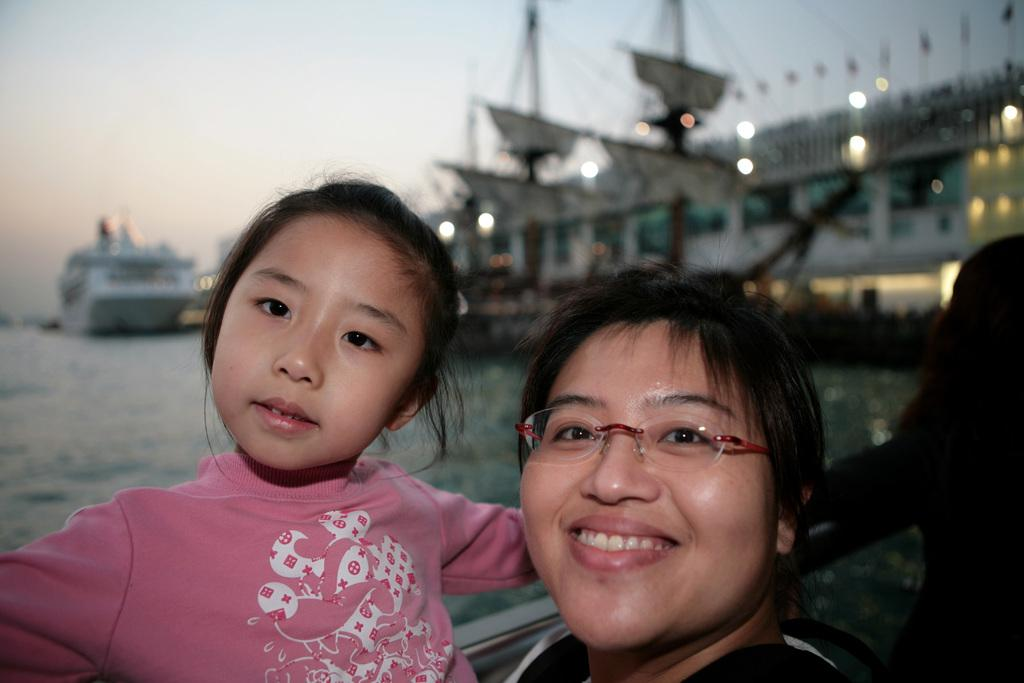How many people are in the foreground of the image? There are three persons in the foreground of the image. What are the persons near in the image? The persons are near a fence in the image. What can be seen in the background of the image? In the background of the image, there are boats in the water, buildings, lights, and the sky. What might suggest the location of the image? The presence of boats and the possibility that the image was taken near the ocean may suggest a coastal location. Can you describe the size of the giants in the image? There are no giants present in the image. What type of hen can be seen in the image? There is no hen present in the image. 